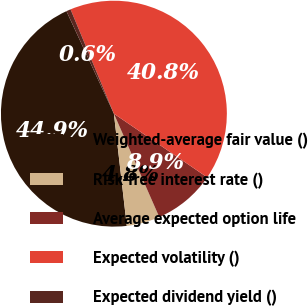<chart> <loc_0><loc_0><loc_500><loc_500><pie_chart><fcel>Weighted-average fair value ()<fcel>Risk-free interest rate ()<fcel>Average expected option life<fcel>Expected volatility ()<fcel>Expected dividend yield ()<nl><fcel>44.92%<fcel>4.76%<fcel>8.89%<fcel>40.8%<fcel>0.63%<nl></chart> 